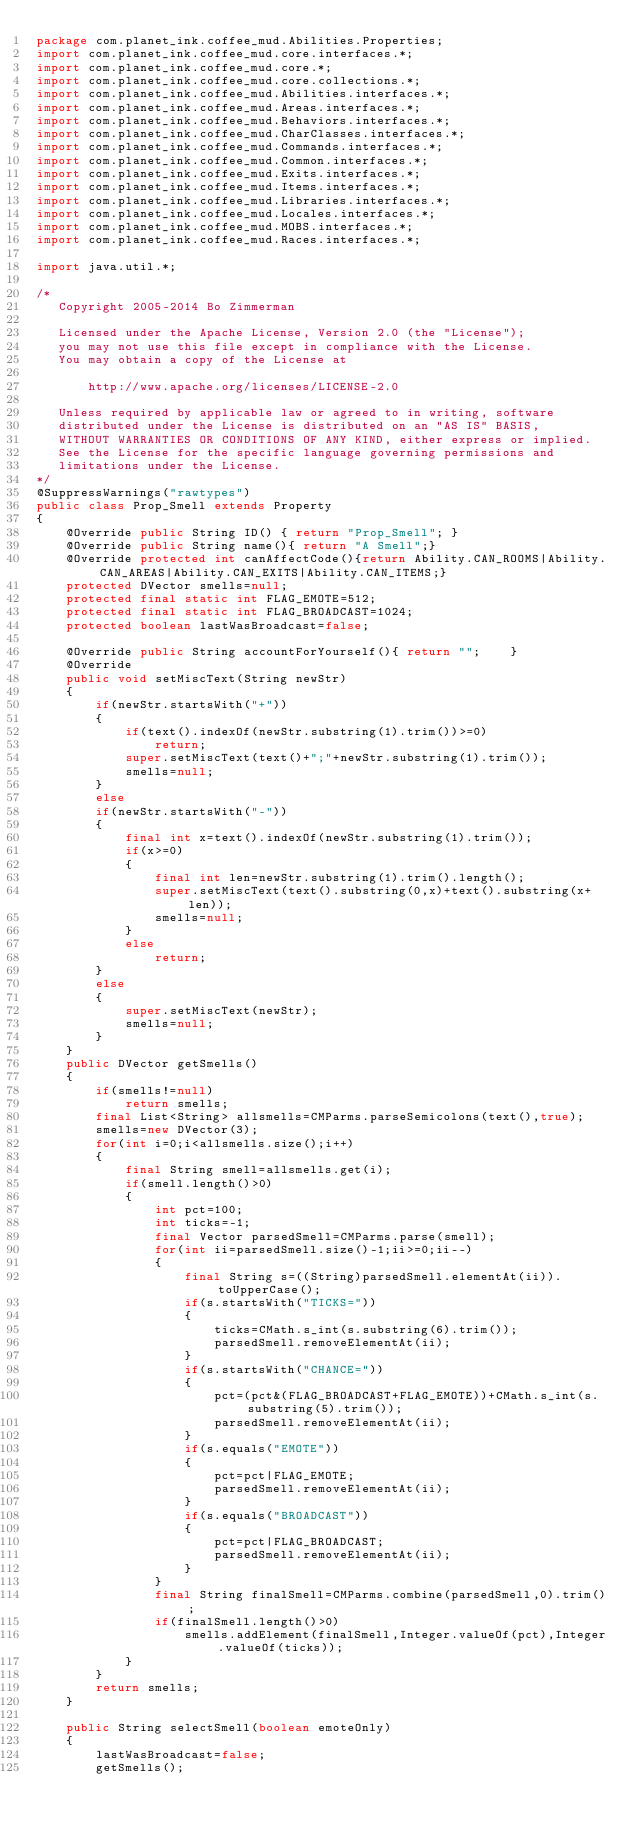<code> <loc_0><loc_0><loc_500><loc_500><_Java_>package com.planet_ink.coffee_mud.Abilities.Properties;
import com.planet_ink.coffee_mud.core.interfaces.*;
import com.planet_ink.coffee_mud.core.*;
import com.planet_ink.coffee_mud.core.collections.*;
import com.planet_ink.coffee_mud.Abilities.interfaces.*;
import com.planet_ink.coffee_mud.Areas.interfaces.*;
import com.planet_ink.coffee_mud.Behaviors.interfaces.*;
import com.planet_ink.coffee_mud.CharClasses.interfaces.*;
import com.planet_ink.coffee_mud.Commands.interfaces.*;
import com.planet_ink.coffee_mud.Common.interfaces.*;
import com.planet_ink.coffee_mud.Exits.interfaces.*;
import com.planet_ink.coffee_mud.Items.interfaces.*;
import com.planet_ink.coffee_mud.Libraries.interfaces.*;
import com.planet_ink.coffee_mud.Locales.interfaces.*;
import com.planet_ink.coffee_mud.MOBS.interfaces.*;
import com.planet_ink.coffee_mud.Races.interfaces.*;

import java.util.*;

/*
   Copyright 2005-2014 Bo Zimmerman

   Licensed under the Apache License, Version 2.0 (the "License");
   you may not use this file except in compliance with the License.
   You may obtain a copy of the License at

	   http://www.apache.org/licenses/LICENSE-2.0

   Unless required by applicable law or agreed to in writing, software
   distributed under the License is distributed on an "AS IS" BASIS,
   WITHOUT WARRANTIES OR CONDITIONS OF ANY KIND, either express or implied.
   See the License for the specific language governing permissions and
   limitations under the License.
*/
@SuppressWarnings("rawtypes")
public class Prop_Smell extends Property
{
	@Override public String ID() { return "Prop_Smell"; }
	@Override public String name(){ return "A Smell";}
	@Override protected int canAffectCode(){return Ability.CAN_ROOMS|Ability.CAN_AREAS|Ability.CAN_EXITS|Ability.CAN_ITEMS;}
	protected DVector smells=null;
	protected final static int FLAG_EMOTE=512;
	protected final static int FLAG_BROADCAST=1024;
	protected boolean lastWasBroadcast=false;

	@Override public String accountForYourself(){ return "";	}
	@Override
	public void setMiscText(String newStr)
	{
		if(newStr.startsWith("+"))
		{
			if(text().indexOf(newStr.substring(1).trim())>=0)
				return;
			super.setMiscText(text()+";"+newStr.substring(1).trim());
			smells=null;
		}
		else
		if(newStr.startsWith("-"))
		{
			final int x=text().indexOf(newStr.substring(1).trim());
			if(x>=0)
			{
				final int len=newStr.substring(1).trim().length();
				super.setMiscText(text().substring(0,x)+text().substring(x+len));
				smells=null;
			}
			else
				return;
		}
		else
		{
			super.setMiscText(newStr);
			smells=null;
		}
	}
	public DVector getSmells()
	{
		if(smells!=null)
			return smells;
		final List<String> allsmells=CMParms.parseSemicolons(text(),true);
		smells=new DVector(3);
		for(int i=0;i<allsmells.size();i++)
		{
			final String smell=allsmells.get(i);
			if(smell.length()>0)
			{
				int pct=100;
				int ticks=-1;
				final Vector parsedSmell=CMParms.parse(smell);
				for(int ii=parsedSmell.size()-1;ii>=0;ii--)
				{
					final String s=((String)parsedSmell.elementAt(ii)).toUpperCase();
					if(s.startsWith("TICKS="))
					{
						ticks=CMath.s_int(s.substring(6).trim());
						parsedSmell.removeElementAt(ii);
					}
					if(s.startsWith("CHANCE="))
					{
						pct=(pct&(FLAG_BROADCAST+FLAG_EMOTE))+CMath.s_int(s.substring(5).trim());
						parsedSmell.removeElementAt(ii);
					}
					if(s.equals("EMOTE"))
					{
						pct=pct|FLAG_EMOTE;
						parsedSmell.removeElementAt(ii);
					}
					if(s.equals("BROADCAST"))
					{
						pct=pct|FLAG_BROADCAST;
						parsedSmell.removeElementAt(ii);
					}
				}
				final String finalSmell=CMParms.combine(parsedSmell,0).trim();
				if(finalSmell.length()>0)
					smells.addElement(finalSmell,Integer.valueOf(pct),Integer.valueOf(ticks));
			}
		}
		return smells;
	}

	public String selectSmell(boolean emoteOnly)
	{
		lastWasBroadcast=false;
		getSmells();</code> 